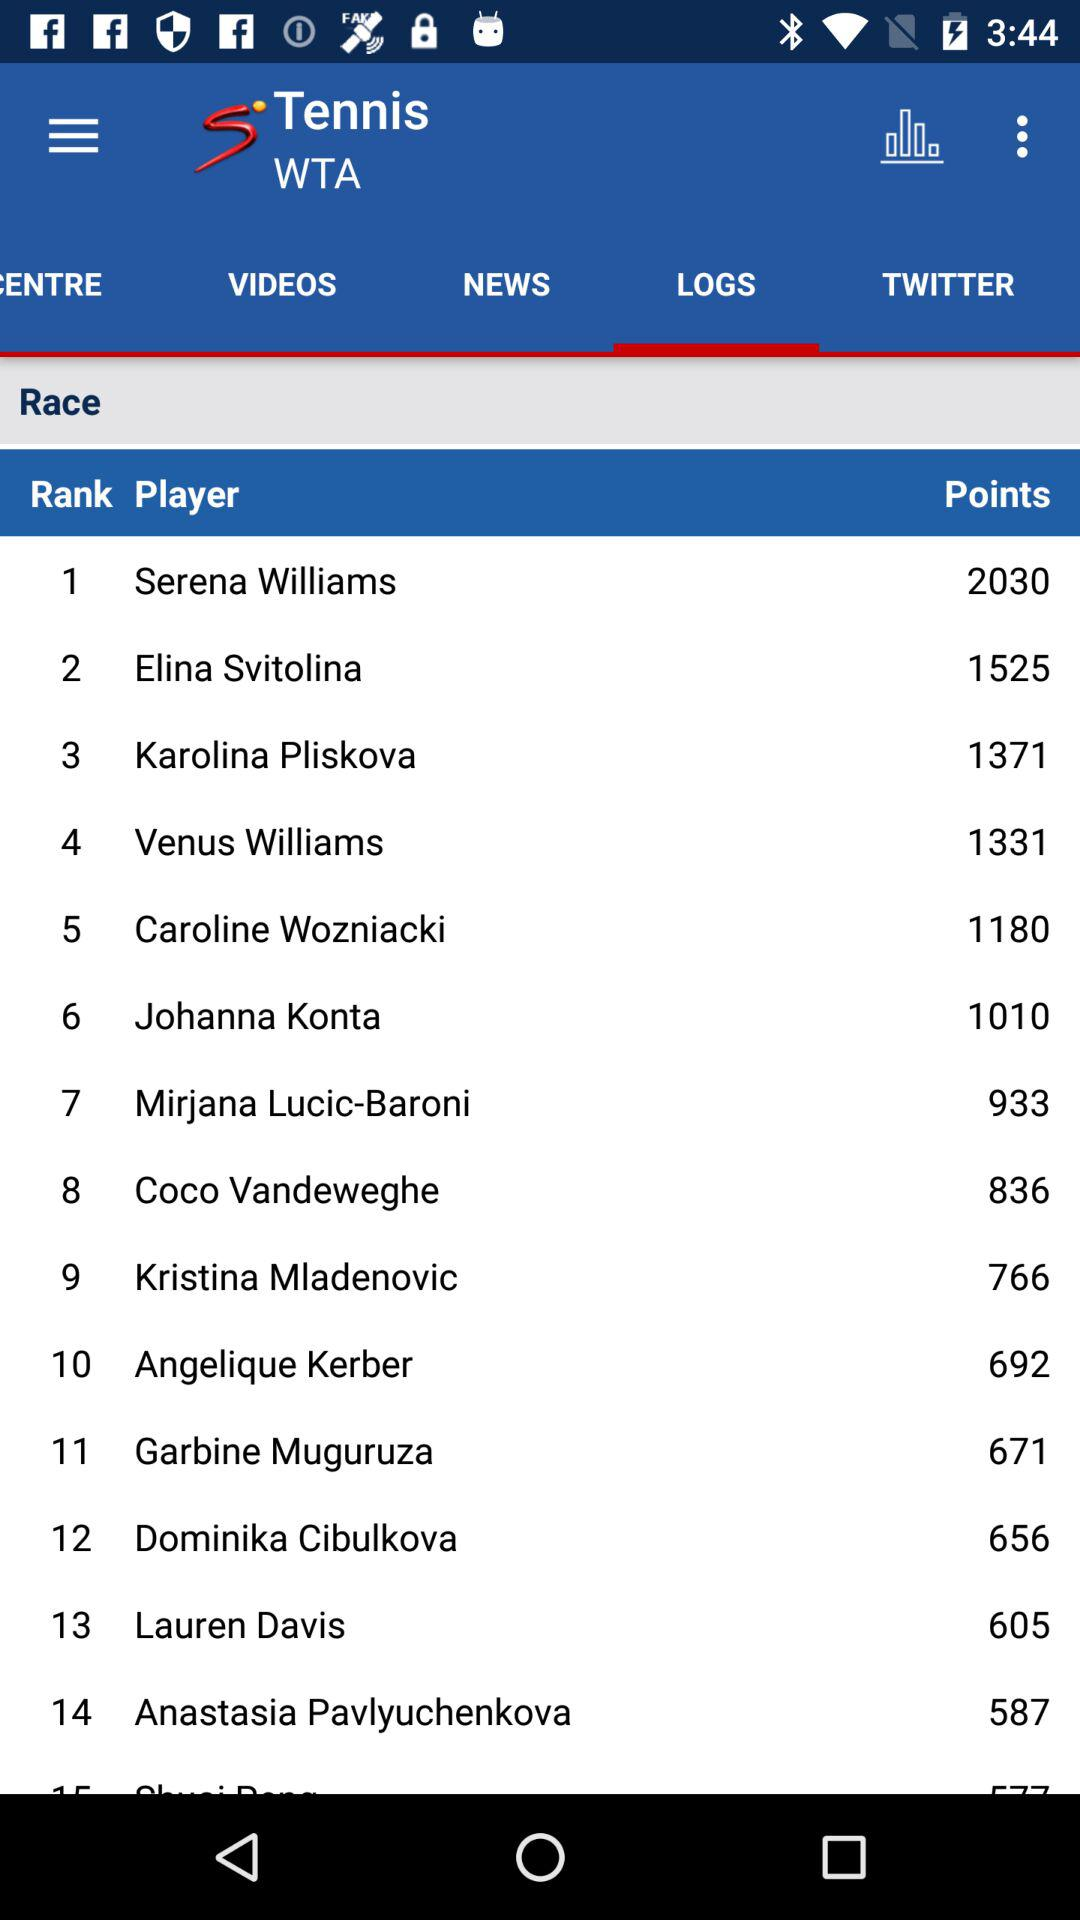Which option has been selected? The option that has been selected is "LOGS". 